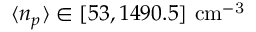Convert formula to latex. <formula><loc_0><loc_0><loc_500><loc_500>\langle n _ { p } \rangle \in [ 5 3 , 1 4 9 0 . 5 ] c m ^ { - 3 }</formula> 